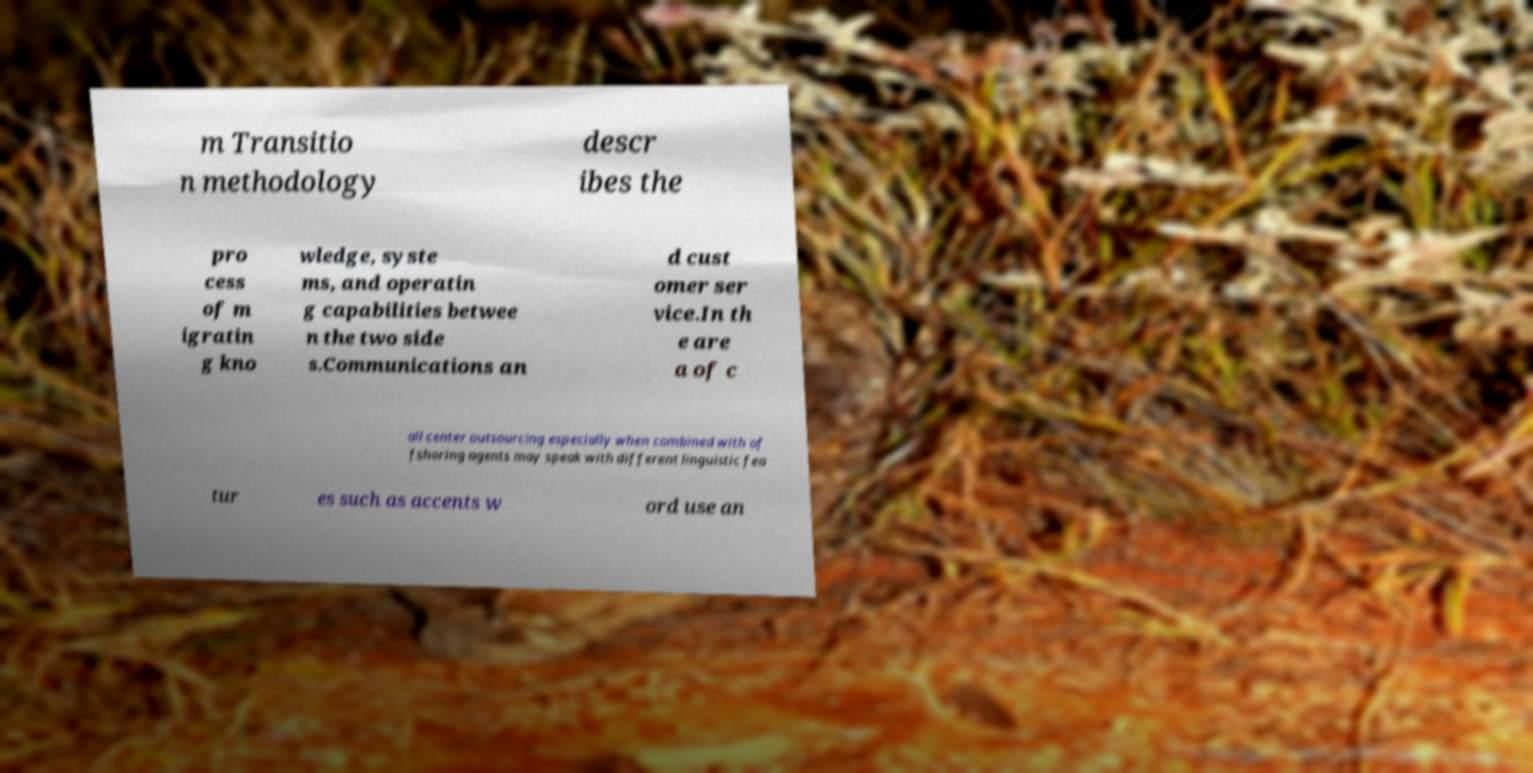Please identify and transcribe the text found in this image. m Transitio n methodology descr ibes the pro cess of m igratin g kno wledge, syste ms, and operatin g capabilities betwee n the two side s.Communications an d cust omer ser vice.In th e are a of c all center outsourcing especially when combined with of fshoring agents may speak with different linguistic fea tur es such as accents w ord use an 